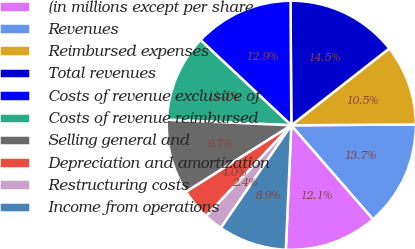Convert chart. <chart><loc_0><loc_0><loc_500><loc_500><pie_chart><fcel>(in millions except per share<fcel>Revenues<fcel>Reimbursed expenses<fcel>Total revenues<fcel>Costs of revenue exclusive of<fcel>Costs of revenue reimbursed<fcel>Selling general and<fcel>Depreciation and amortization<fcel>Restructuring costs<fcel>Income from operations<nl><fcel>12.1%<fcel>13.71%<fcel>10.48%<fcel>14.51%<fcel>12.9%<fcel>11.29%<fcel>9.68%<fcel>4.03%<fcel>2.42%<fcel>8.87%<nl></chart> 